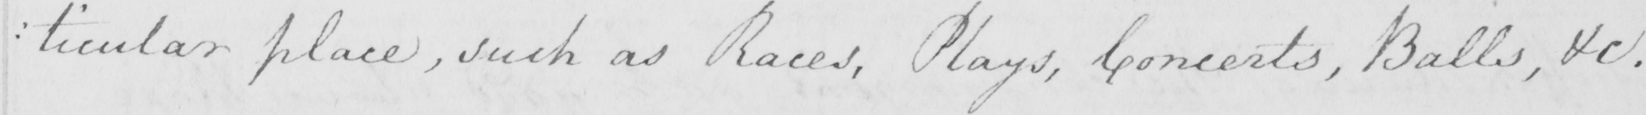Can you tell me what this handwritten text says? : ticular place , such as Races , Plays , Concerts , Balls , &c . 